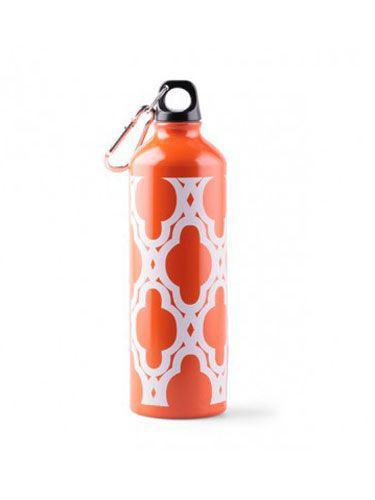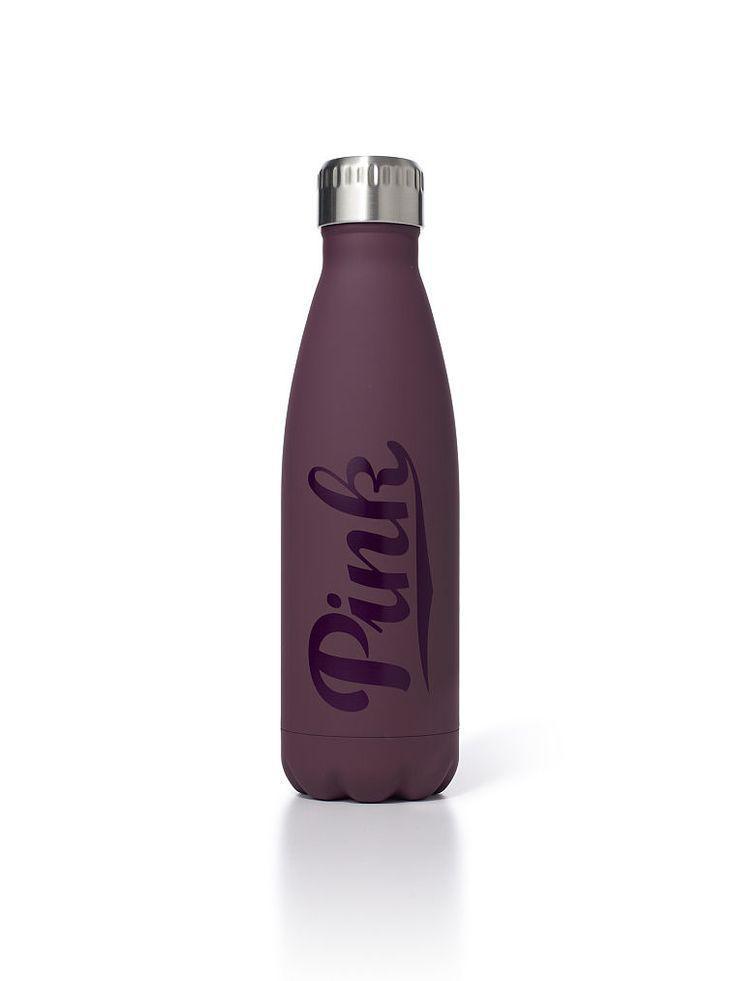The first image is the image on the left, the second image is the image on the right. Examine the images to the left and right. Is the description "One bottle has a round hole in the cap, and another bottle has an irregularly shaped hole in the cap." accurate? Answer yes or no. No. The first image is the image on the left, the second image is the image on the right. For the images shown, is this caption "A water bottle is decorated with three rows of letters on squares that spell out a word." true? Answer yes or no. No. 